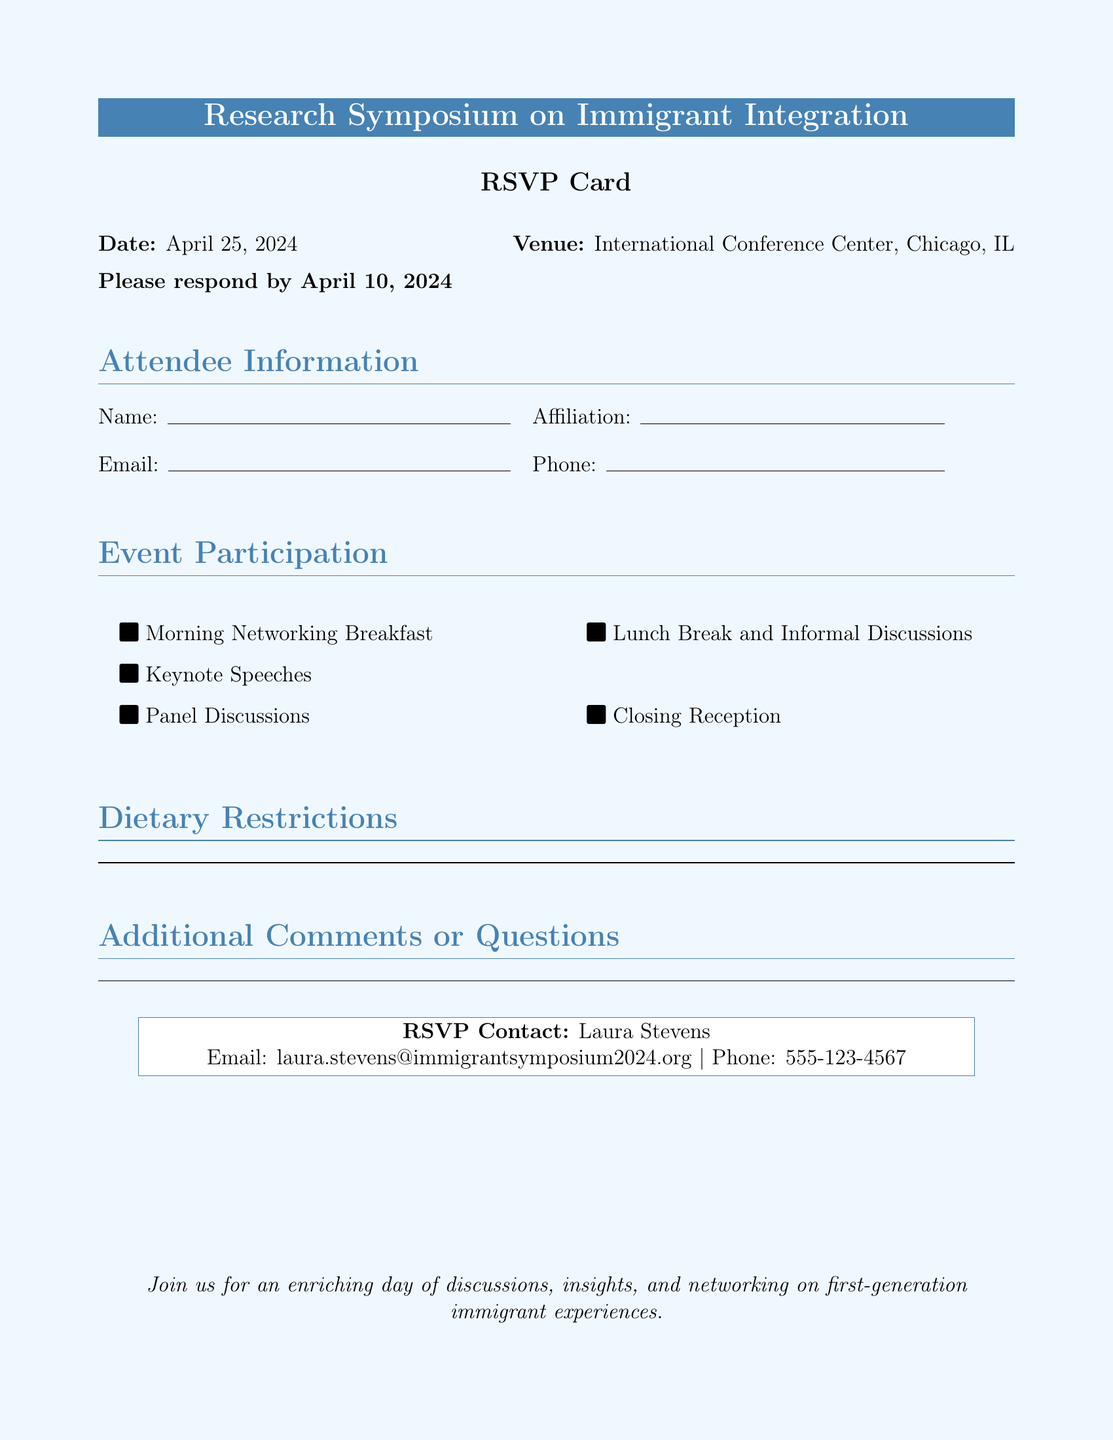What is the date of the symposium? The date is explicitly stated in the document as April 25, 2024.
Answer: April 25, 2024 Where is the symposium being held? The venue is mentioned in the document as the International Conference Center, Chicago, IL.
Answer: International Conference Center, Chicago, IL What is the deadline to RSVP? The document specifies the RSVP deadline as April 10, 2024.
Answer: April 10, 2024 Who is the RSVP contact person? The contact person for RSVPs is named in the document as Laura Stevens.
Answer: Laura Stevens What are the types of participation events listed? The document lists various events including Morning Networking Breakfast, Keynote Speeches, Panel Discussions, Lunch Break and Informal Discussions, and Closing Reception.
Answer: Morning Networking Breakfast, Keynote Speeches, Panel Discussions, Lunch Break and Informal Discussions, Closing Reception What dietary information is requested? The document explicitly asks for dietary restrictions to be noted.
Answer: Dietary restrictions How many different types of event participation are listed? The document lists a total of five types of event participation.
Answer: Five What kind of comments or feedback can attendees provide? The document allows for additional comments or questions to be provided, indicating an open section for input.
Answer: Additional comments or questions 